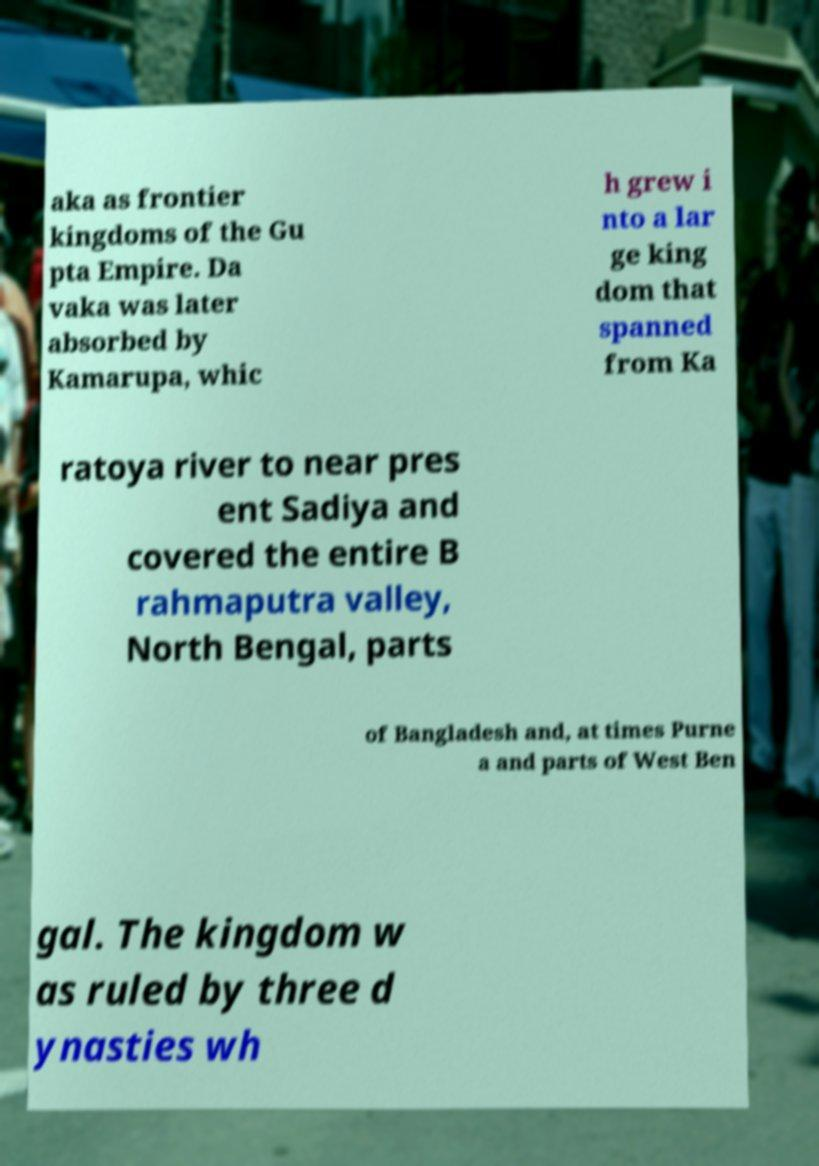Can you read and provide the text displayed in the image?This photo seems to have some interesting text. Can you extract and type it out for me? aka as frontier kingdoms of the Gu pta Empire. Da vaka was later absorbed by Kamarupa, whic h grew i nto a lar ge king dom that spanned from Ka ratoya river to near pres ent Sadiya and covered the entire B rahmaputra valley, North Bengal, parts of Bangladesh and, at times Purne a and parts of West Ben gal. The kingdom w as ruled by three d ynasties wh 